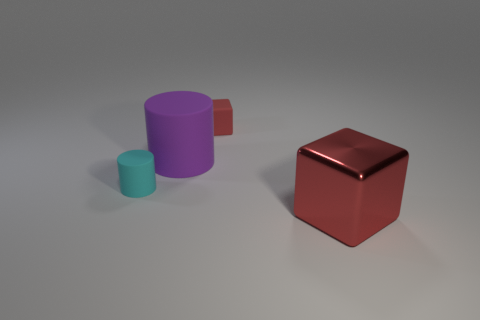Are there any other things that have the same material as the large red cube?
Your answer should be very brief. No. Does the tiny thing on the left side of the large matte object have the same material as the large red block?
Your answer should be compact. No. What material is the block that is behind the metallic object that is right of the large object that is behind the big metallic object?
Ensure brevity in your answer.  Rubber. How many other objects are the same shape as the purple thing?
Offer a very short reply. 1. What color is the small thing that is in front of the purple rubber object?
Provide a short and direct response. Cyan. There is a cube that is left of the large cube on the right side of the big purple rubber object; what number of large red blocks are left of it?
Offer a very short reply. 0. There is a block that is in front of the small red object; how many cyan objects are right of it?
Make the answer very short. 0. What number of small red rubber things are to the right of the large red metallic block?
Provide a short and direct response. 0. How many other objects are there of the same size as the red metal cube?
Offer a very short reply. 1. What is the size of the matte thing that is the same shape as the red shiny thing?
Offer a very short reply. Small. 